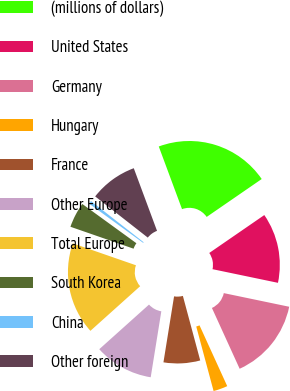Convert chart to OTSL. <chart><loc_0><loc_0><loc_500><loc_500><pie_chart><fcel>(millions of dollars)<fcel>United States<fcel>Germany<fcel>Hungary<fcel>France<fcel>Other Europe<fcel>Total Europe<fcel>South Korea<fcel>China<fcel>Other foreign<nl><fcel>21.06%<fcel>12.87%<fcel>14.92%<fcel>2.63%<fcel>6.72%<fcel>10.82%<fcel>16.96%<fcel>4.67%<fcel>0.58%<fcel>8.77%<nl></chart> 